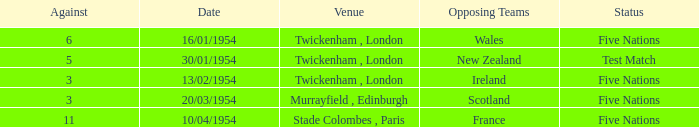What is the lowest against for games played in the stade colombes, paris venue? 11.0. 